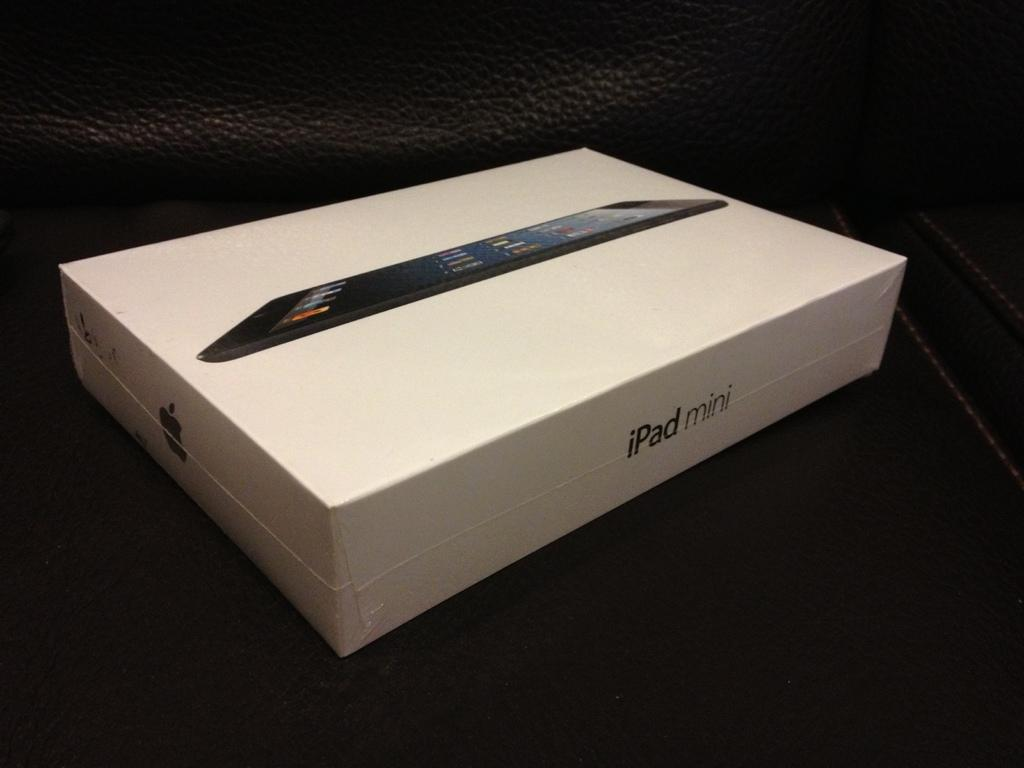<image>
Offer a succinct explanation of the picture presented. A white iPad mini box has an image of the device on the box. 